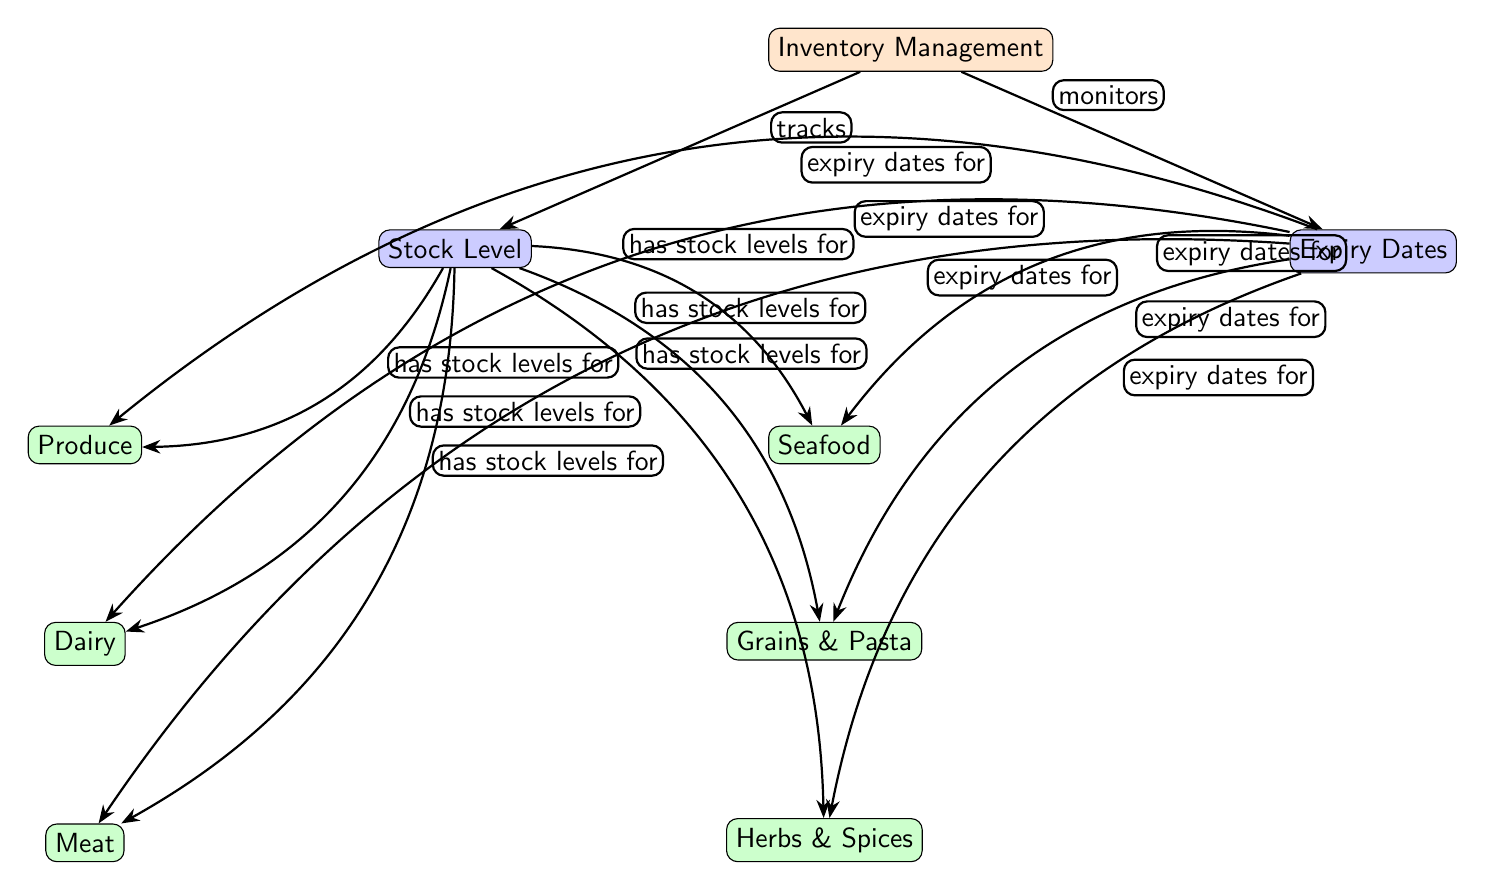What is the main focus of the diagram? The main focus of the diagram is on "Inventory Management," as indicated by the top-level node.
Answer: Inventory Management How many stock level types are shown in the diagram? The diagram lists six types of stock levels: Produce, Dairy, Meat, Seafood, Grains & Pasta, and Herbs & Spices. Therefore, the count is six.
Answer: 6 Which level displays the "Stock Level" information? The "Stock Level" information is represented in the second level of the diagram, directly connected to the main node "Inventory Management."
Answer: Stock Level What is the relationship described between "Inventory Management" and "Expiry Dates"? The diagram indicates that "Inventory Management" monitors "Expiry Dates," showing a direct connection and direction of the arrow from the main node.
Answer: monitors Which type of food has an expiry date in the diagram? All six food types (Produce, Dairy, Meat, Seafood, Grains & Pasta, and Herbs & Spices) are associated with expiry dates according to the diagram.
Answer: All What is the purpose of the arrows connecting "Stock Level" and "Expiry Dates" to each food type? The arrows illustrate that each food type has both stock levels and expiry dates, indicating dual categorization and management for each item.
Answer: Dual categorization What color represents "Level 1" in the diagram? In the diagram, "Level 1" is colored orange, delineating it from other levels.
Answer: orange Which food type is directly below "Dairy"? The food type directly below "Dairy" is "Meat," as positioned in the diagram hierarchy.
Answer: Meat How many arrows lead from "Inventory Management" to the subcategories? There are two arrows leading from "Inventory Management," one indicating stock level and another indicating expiry dates, each extending to the subcategories.
Answer: 2 